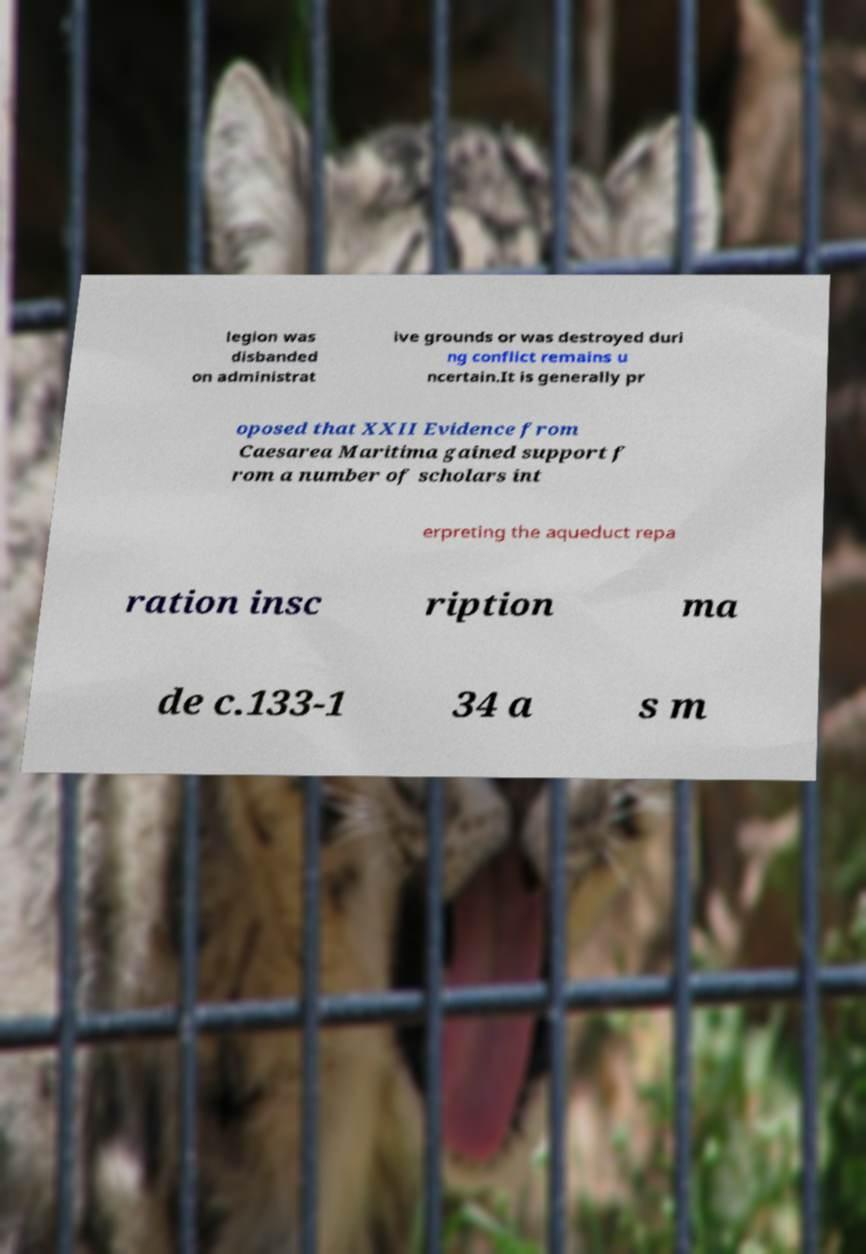Please read and relay the text visible in this image. What does it say? legion was disbanded on administrat ive grounds or was destroyed duri ng conflict remains u ncertain.It is generally pr oposed that XXII Evidence from Caesarea Maritima gained support f rom a number of scholars int erpreting the aqueduct repa ration insc ription ma de c.133-1 34 a s m 